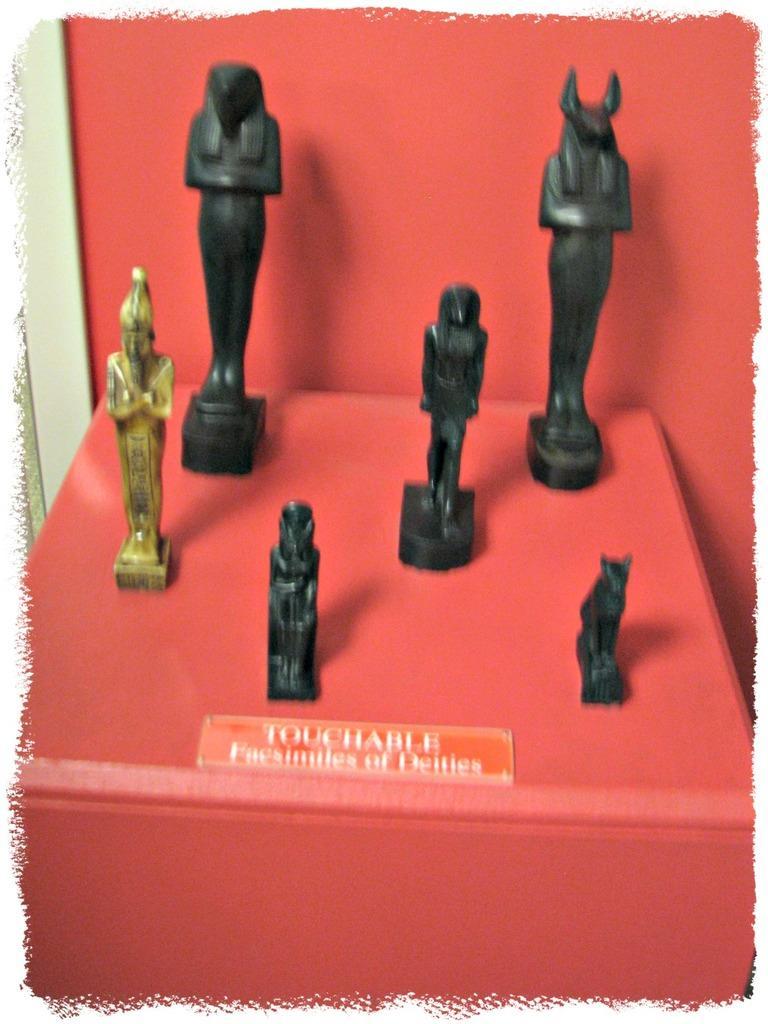In one or two sentences, can you explain what this image depicts? In this picture we can see statues and a name plate and these are placed on a red platform. 